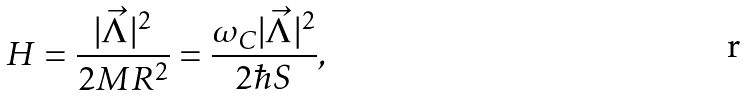Convert formula to latex. <formula><loc_0><loc_0><loc_500><loc_500>H = \frac { | \vec { \Lambda } | ^ { 2 } } { 2 M R ^ { 2 } } = \frac { \omega _ { C } | \vec { \Lambda } | ^ { 2 } } { 2 \hbar { S } } ,</formula> 